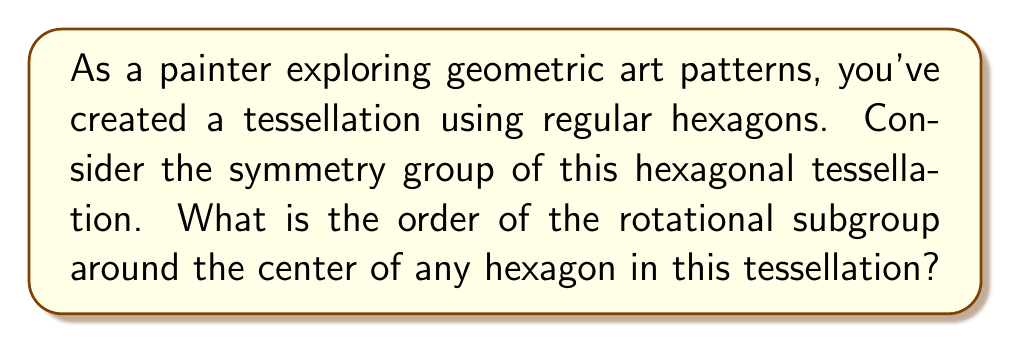Help me with this question. To answer this question, let's approach it step-by-step:

1) First, recall that the symmetry group of a regular hexagon includes rotational and reflectional symmetries.

2) In a hexagonal tessellation, we're focusing on the rotations around the center of a single hexagon.

3) A regular hexagon has 6-fold rotational symmetry, meaning it can be rotated by multiples of 60° (or $\frac{\pi}{3}$ radians) and still look the same.

4) The possible rotations are:
   - 0° (identity)
   - 60° ($\frac{\pi}{3}$)
   - 120° ($\frac{2\pi}{3}$)
   - 180° ($\pi$)
   - 240° ($\frac{4\pi}{3}$)
   - 300° ($\frac{5\pi}{3}$)

5) Each of these rotations forms an element of the rotational subgroup.

6) The order of a group is the number of elements in the group.

7) Therefore, the order of the rotational subgroup is 6.

This rotational subgroup is isomorphic to the cyclic group $C_6$ or $\mathbb{Z}_6$.

[asy]
import geometry;

pair center = (0,0);
real radius = 1;
int n = 6;

for(int i = 0; i < n; ++i) {
  draw(center -- (radius*cos(2pi*i/n), radius*sin(2pi*i/n)));
}

draw(circle(center, radius));

label("60°", (0.7,0.4));
draw(arc(center, (0.5,0), 60), Arrow);
[/asy]

The diagram above illustrates a regular hexagon with one of its 60° rotations indicated.
Answer: The order of the rotational subgroup around the center of any hexagon in this tessellation is 6. 